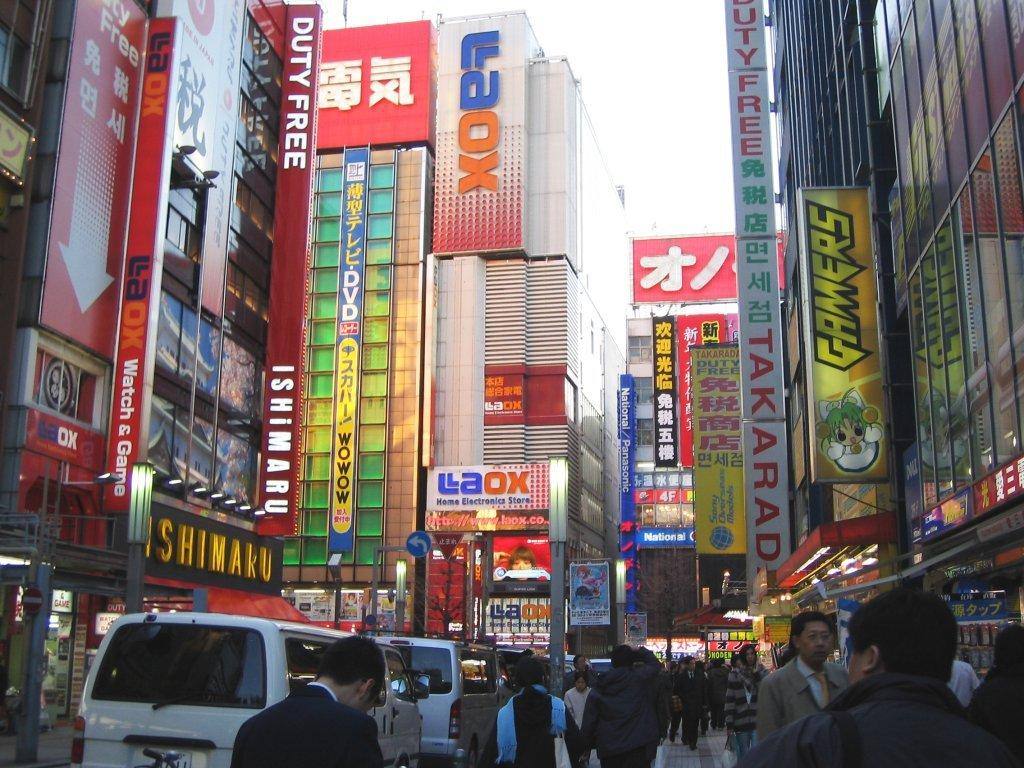What can you describe the vehicles at the bottom of the image? There are vehicles at the bottom of the image, but their specific details are not mentioned in the facts. What else can be seen in the image besides the vehicles? There are people, buildings, windows, hoardings, lights, objects, and the sky visible in the background of the image. Can you describe the buildings in the background? The buildings in the background have windows and are located near hoardings and lights. What is the color of the sky in the background of the image? The sky is visible in the background of the image, but its color is not mentioned in the facts. What is the name of the muscle that can be seen flexing in the image? There is no muscle visible in the image, as it primarily features vehicles, people, buildings, and the sky. Can you describe how the people in the image are touching each other? The facts do not mention any physical contact between people in the image, so it is not possible to describe how they are touching each other. 